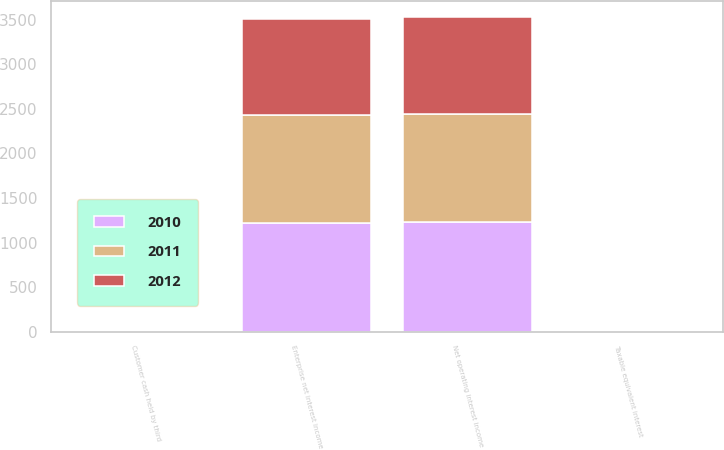Convert chart to OTSL. <chart><loc_0><loc_0><loc_500><loc_500><stacked_bar_chart><ecel><fcel>Enterprise net interest income<fcel>Taxable equivalent interest<fcel>Customer cash held by third<fcel>Net operating interest income<nl><fcel>2012<fcel>1077.7<fcel>1.1<fcel>8.5<fcel>1085.1<nl><fcel>2011<fcel>1213.9<fcel>1.2<fcel>7.3<fcel>1220<nl><fcel>2010<fcel>1219.1<fcel>1.2<fcel>8.4<fcel>1226.3<nl></chart> 